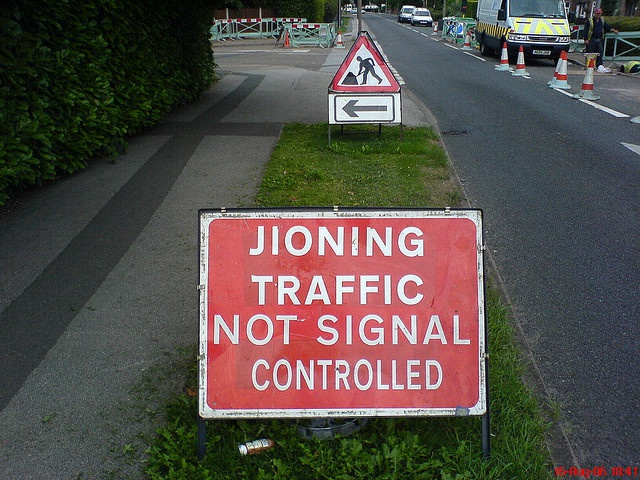Describe the objects in this image and their specific colors. I can see truck in black, gray, lightgray, and darkgray tones, people in black, gray, darkgray, and maroon tones, car in black, white, and gray tones, car in black, white, and gray tones, and car in black, teal, darkgray, and gray tones in this image. 